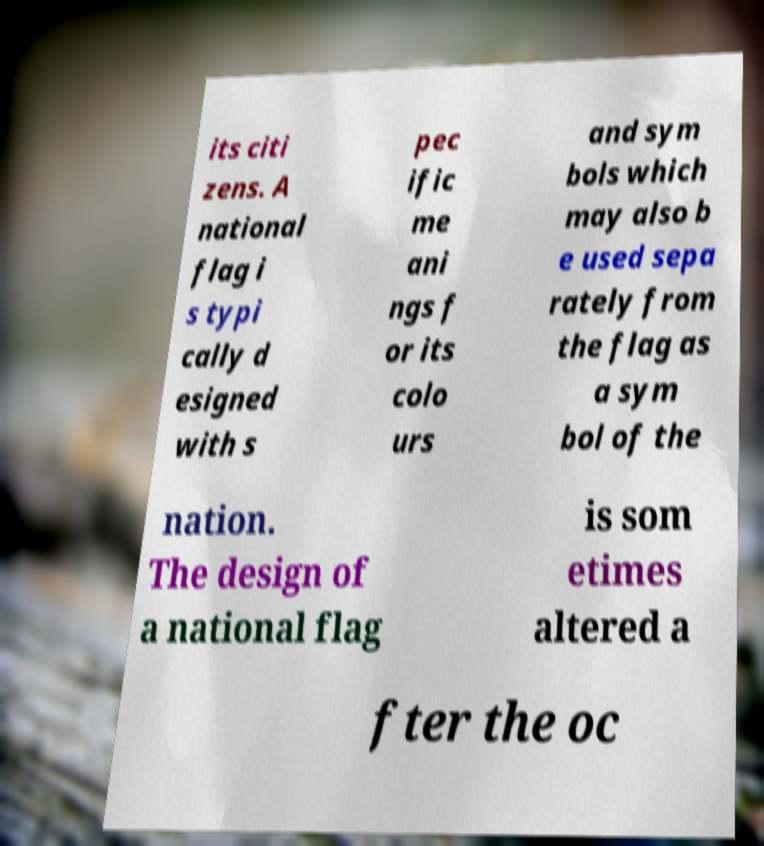I need the written content from this picture converted into text. Can you do that? its citi zens. A national flag i s typi cally d esigned with s pec ific me ani ngs f or its colo urs and sym bols which may also b e used sepa rately from the flag as a sym bol of the nation. The design of a national flag is som etimes altered a fter the oc 